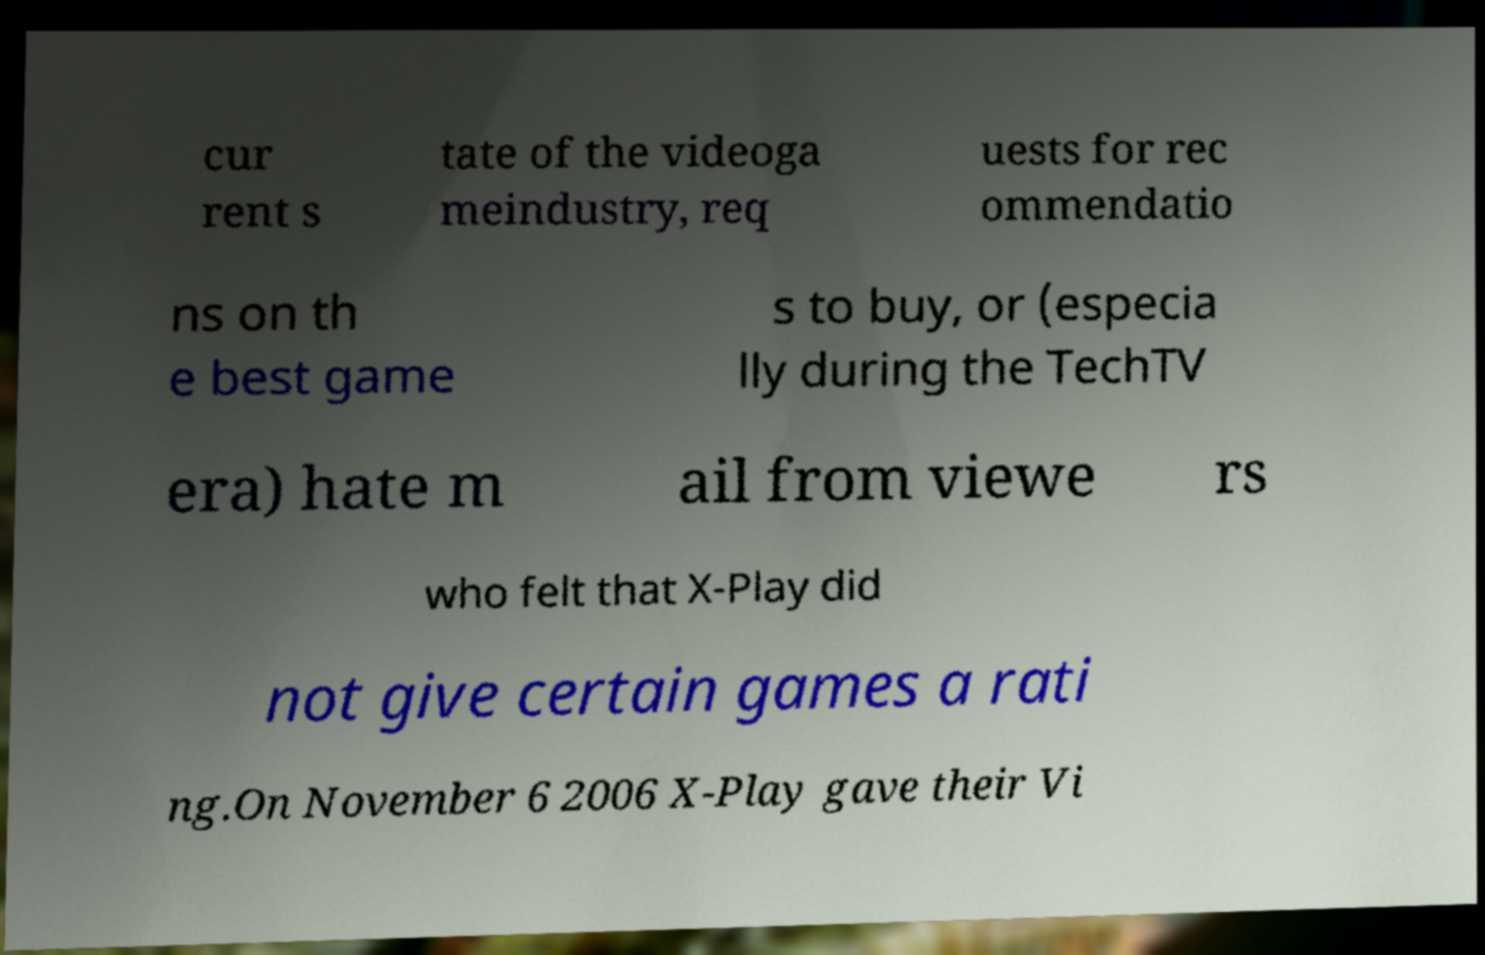Please identify and transcribe the text found in this image. cur rent s tate of the videoga meindustry, req uests for rec ommendatio ns on th e best game s to buy, or (especia lly during the TechTV era) hate m ail from viewe rs who felt that X-Play did not give certain games a rati ng.On November 6 2006 X-Play gave their Vi 